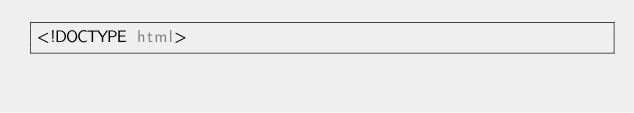Convert code to text. <code><loc_0><loc_0><loc_500><loc_500><_HTML_><!DOCTYPE html></code> 